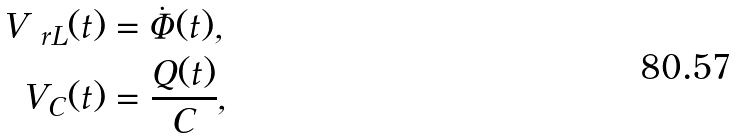<formula> <loc_0><loc_0><loc_500><loc_500>V _ { \ r L } ( t ) & = \dot { \Phi } ( t ) , \\ V _ { C } ( t ) & = \frac { Q ( t ) } { C } ,</formula> 